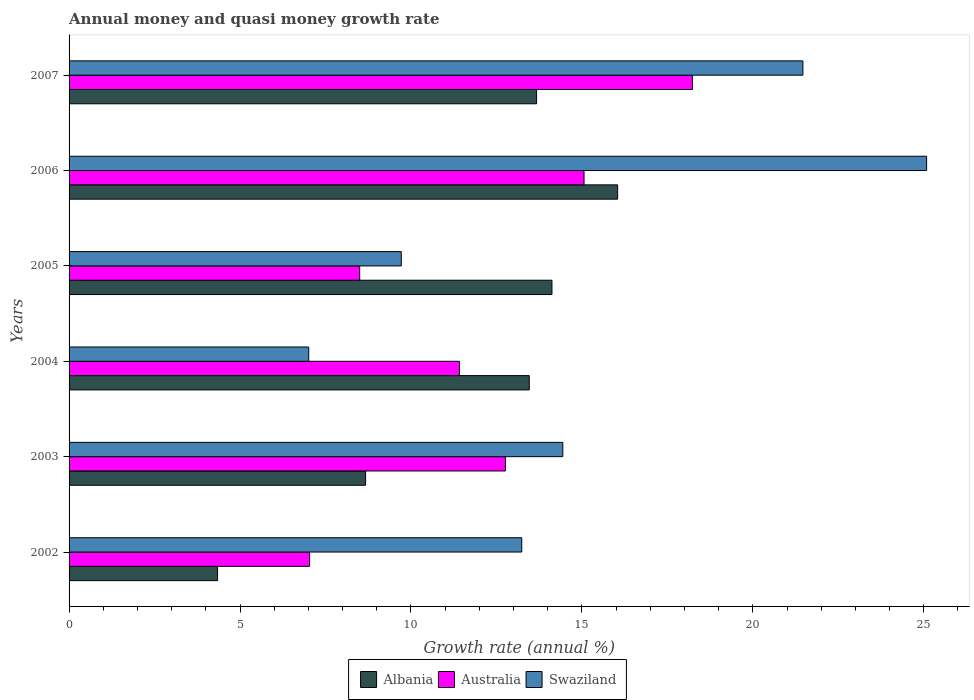Are the number of bars per tick equal to the number of legend labels?
Provide a short and direct response. Yes. How many bars are there on the 5th tick from the bottom?
Your answer should be very brief. 3. In how many cases, is the number of bars for a given year not equal to the number of legend labels?
Your response must be concise. 0. What is the growth rate in Swaziland in 2002?
Provide a succinct answer. 13.24. Across all years, what is the maximum growth rate in Albania?
Give a very brief answer. 16.05. Across all years, what is the minimum growth rate in Australia?
Your answer should be compact. 7.04. In which year was the growth rate in Albania maximum?
Offer a very short reply. 2006. In which year was the growth rate in Australia minimum?
Offer a terse response. 2002. What is the total growth rate in Albania in the graph?
Offer a terse response. 70.32. What is the difference between the growth rate in Australia in 2002 and that in 2005?
Offer a very short reply. -1.46. What is the difference between the growth rate in Albania in 2006 and the growth rate in Swaziland in 2003?
Your response must be concise. 1.6. What is the average growth rate in Albania per year?
Offer a very short reply. 11.72. In the year 2005, what is the difference between the growth rate in Australia and growth rate in Albania?
Offer a very short reply. -5.62. In how many years, is the growth rate in Australia greater than 19 %?
Provide a short and direct response. 0. What is the ratio of the growth rate in Swaziland in 2004 to that in 2006?
Your answer should be compact. 0.28. What is the difference between the highest and the second highest growth rate in Australia?
Give a very brief answer. 3.17. What is the difference between the highest and the lowest growth rate in Australia?
Give a very brief answer. 11.2. What does the 3rd bar from the top in 2003 represents?
Offer a terse response. Albania. What does the 1st bar from the bottom in 2005 represents?
Give a very brief answer. Albania. Is it the case that in every year, the sum of the growth rate in Swaziland and growth rate in Australia is greater than the growth rate in Albania?
Provide a succinct answer. Yes. How many bars are there?
Your answer should be very brief. 18. Are all the bars in the graph horizontal?
Provide a short and direct response. Yes. How many years are there in the graph?
Your answer should be very brief. 6. What is the difference between two consecutive major ticks on the X-axis?
Provide a short and direct response. 5. Does the graph contain grids?
Provide a short and direct response. No. What is the title of the graph?
Provide a succinct answer. Annual money and quasi money growth rate. What is the label or title of the X-axis?
Your response must be concise. Growth rate (annual %). What is the Growth rate (annual %) in Albania in 2002?
Your answer should be compact. 4.34. What is the Growth rate (annual %) in Australia in 2002?
Provide a succinct answer. 7.04. What is the Growth rate (annual %) of Swaziland in 2002?
Keep it short and to the point. 13.24. What is the Growth rate (annual %) in Albania in 2003?
Provide a short and direct response. 8.67. What is the Growth rate (annual %) of Australia in 2003?
Provide a short and direct response. 12.76. What is the Growth rate (annual %) of Swaziland in 2003?
Keep it short and to the point. 14.44. What is the Growth rate (annual %) in Albania in 2004?
Keep it short and to the point. 13.46. What is the Growth rate (annual %) of Australia in 2004?
Keep it short and to the point. 11.42. What is the Growth rate (annual %) in Swaziland in 2004?
Ensure brevity in your answer.  7.01. What is the Growth rate (annual %) of Albania in 2005?
Provide a succinct answer. 14.13. What is the Growth rate (annual %) in Australia in 2005?
Give a very brief answer. 8.5. What is the Growth rate (annual %) in Swaziland in 2005?
Ensure brevity in your answer.  9.72. What is the Growth rate (annual %) in Albania in 2006?
Make the answer very short. 16.05. What is the Growth rate (annual %) in Australia in 2006?
Provide a short and direct response. 15.06. What is the Growth rate (annual %) in Swaziland in 2006?
Keep it short and to the point. 25.08. What is the Growth rate (annual %) of Albania in 2007?
Offer a very short reply. 13.67. What is the Growth rate (annual %) in Australia in 2007?
Offer a terse response. 18.23. What is the Growth rate (annual %) of Swaziland in 2007?
Ensure brevity in your answer.  21.47. Across all years, what is the maximum Growth rate (annual %) of Albania?
Offer a terse response. 16.05. Across all years, what is the maximum Growth rate (annual %) in Australia?
Your response must be concise. 18.23. Across all years, what is the maximum Growth rate (annual %) of Swaziland?
Keep it short and to the point. 25.08. Across all years, what is the minimum Growth rate (annual %) in Albania?
Your answer should be compact. 4.34. Across all years, what is the minimum Growth rate (annual %) of Australia?
Keep it short and to the point. 7.04. Across all years, what is the minimum Growth rate (annual %) in Swaziland?
Your answer should be very brief. 7.01. What is the total Growth rate (annual %) of Albania in the graph?
Give a very brief answer. 70.32. What is the total Growth rate (annual %) in Australia in the graph?
Ensure brevity in your answer.  73.01. What is the total Growth rate (annual %) of Swaziland in the graph?
Give a very brief answer. 90.96. What is the difference between the Growth rate (annual %) of Albania in 2002 and that in 2003?
Your answer should be very brief. -4.33. What is the difference between the Growth rate (annual %) in Australia in 2002 and that in 2003?
Give a very brief answer. -5.73. What is the difference between the Growth rate (annual %) of Swaziland in 2002 and that in 2003?
Provide a short and direct response. -1.2. What is the difference between the Growth rate (annual %) in Albania in 2002 and that in 2004?
Your response must be concise. -9.12. What is the difference between the Growth rate (annual %) of Australia in 2002 and that in 2004?
Ensure brevity in your answer.  -4.38. What is the difference between the Growth rate (annual %) of Swaziland in 2002 and that in 2004?
Your answer should be very brief. 6.23. What is the difference between the Growth rate (annual %) of Albania in 2002 and that in 2005?
Offer a very short reply. -9.78. What is the difference between the Growth rate (annual %) in Australia in 2002 and that in 2005?
Provide a succinct answer. -1.46. What is the difference between the Growth rate (annual %) of Swaziland in 2002 and that in 2005?
Provide a succinct answer. 3.52. What is the difference between the Growth rate (annual %) of Albania in 2002 and that in 2006?
Provide a succinct answer. -11.7. What is the difference between the Growth rate (annual %) in Australia in 2002 and that in 2006?
Provide a short and direct response. -8.03. What is the difference between the Growth rate (annual %) in Swaziland in 2002 and that in 2006?
Your answer should be compact. -11.84. What is the difference between the Growth rate (annual %) of Albania in 2002 and that in 2007?
Ensure brevity in your answer.  -9.33. What is the difference between the Growth rate (annual %) in Australia in 2002 and that in 2007?
Offer a terse response. -11.2. What is the difference between the Growth rate (annual %) in Swaziland in 2002 and that in 2007?
Your response must be concise. -8.22. What is the difference between the Growth rate (annual %) of Albania in 2003 and that in 2004?
Provide a short and direct response. -4.79. What is the difference between the Growth rate (annual %) of Australia in 2003 and that in 2004?
Give a very brief answer. 1.35. What is the difference between the Growth rate (annual %) of Swaziland in 2003 and that in 2004?
Keep it short and to the point. 7.43. What is the difference between the Growth rate (annual %) of Albania in 2003 and that in 2005?
Your response must be concise. -5.45. What is the difference between the Growth rate (annual %) in Australia in 2003 and that in 2005?
Provide a succinct answer. 4.26. What is the difference between the Growth rate (annual %) of Swaziland in 2003 and that in 2005?
Provide a succinct answer. 4.72. What is the difference between the Growth rate (annual %) in Albania in 2003 and that in 2006?
Make the answer very short. -7.37. What is the difference between the Growth rate (annual %) of Australia in 2003 and that in 2006?
Your response must be concise. -2.3. What is the difference between the Growth rate (annual %) of Swaziland in 2003 and that in 2006?
Your answer should be compact. -10.64. What is the difference between the Growth rate (annual %) in Albania in 2003 and that in 2007?
Offer a very short reply. -5. What is the difference between the Growth rate (annual %) in Australia in 2003 and that in 2007?
Make the answer very short. -5.47. What is the difference between the Growth rate (annual %) in Swaziland in 2003 and that in 2007?
Provide a short and direct response. -7.02. What is the difference between the Growth rate (annual %) in Albania in 2004 and that in 2005?
Make the answer very short. -0.66. What is the difference between the Growth rate (annual %) of Australia in 2004 and that in 2005?
Give a very brief answer. 2.92. What is the difference between the Growth rate (annual %) in Swaziland in 2004 and that in 2005?
Offer a very short reply. -2.71. What is the difference between the Growth rate (annual %) in Albania in 2004 and that in 2006?
Ensure brevity in your answer.  -2.58. What is the difference between the Growth rate (annual %) of Australia in 2004 and that in 2006?
Ensure brevity in your answer.  -3.64. What is the difference between the Growth rate (annual %) of Swaziland in 2004 and that in 2006?
Your response must be concise. -18.07. What is the difference between the Growth rate (annual %) in Albania in 2004 and that in 2007?
Provide a succinct answer. -0.21. What is the difference between the Growth rate (annual %) in Australia in 2004 and that in 2007?
Provide a succinct answer. -6.81. What is the difference between the Growth rate (annual %) of Swaziland in 2004 and that in 2007?
Give a very brief answer. -14.46. What is the difference between the Growth rate (annual %) in Albania in 2005 and that in 2006?
Your answer should be compact. -1.92. What is the difference between the Growth rate (annual %) of Australia in 2005 and that in 2006?
Give a very brief answer. -6.56. What is the difference between the Growth rate (annual %) in Swaziland in 2005 and that in 2006?
Your answer should be very brief. -15.37. What is the difference between the Growth rate (annual %) in Albania in 2005 and that in 2007?
Ensure brevity in your answer.  0.45. What is the difference between the Growth rate (annual %) of Australia in 2005 and that in 2007?
Offer a very short reply. -9.73. What is the difference between the Growth rate (annual %) of Swaziland in 2005 and that in 2007?
Provide a succinct answer. -11.75. What is the difference between the Growth rate (annual %) in Albania in 2006 and that in 2007?
Make the answer very short. 2.37. What is the difference between the Growth rate (annual %) of Australia in 2006 and that in 2007?
Your response must be concise. -3.17. What is the difference between the Growth rate (annual %) in Swaziland in 2006 and that in 2007?
Your response must be concise. 3.62. What is the difference between the Growth rate (annual %) of Albania in 2002 and the Growth rate (annual %) of Australia in 2003?
Your answer should be very brief. -8.42. What is the difference between the Growth rate (annual %) in Albania in 2002 and the Growth rate (annual %) in Swaziland in 2003?
Offer a terse response. -10.1. What is the difference between the Growth rate (annual %) of Australia in 2002 and the Growth rate (annual %) of Swaziland in 2003?
Provide a short and direct response. -7.41. What is the difference between the Growth rate (annual %) in Albania in 2002 and the Growth rate (annual %) in Australia in 2004?
Offer a very short reply. -7.07. What is the difference between the Growth rate (annual %) in Albania in 2002 and the Growth rate (annual %) in Swaziland in 2004?
Give a very brief answer. -2.67. What is the difference between the Growth rate (annual %) of Australia in 2002 and the Growth rate (annual %) of Swaziland in 2004?
Ensure brevity in your answer.  0.03. What is the difference between the Growth rate (annual %) of Albania in 2002 and the Growth rate (annual %) of Australia in 2005?
Provide a succinct answer. -4.16. What is the difference between the Growth rate (annual %) in Albania in 2002 and the Growth rate (annual %) in Swaziland in 2005?
Your answer should be very brief. -5.37. What is the difference between the Growth rate (annual %) in Australia in 2002 and the Growth rate (annual %) in Swaziland in 2005?
Provide a succinct answer. -2.68. What is the difference between the Growth rate (annual %) of Albania in 2002 and the Growth rate (annual %) of Australia in 2006?
Ensure brevity in your answer.  -10.72. What is the difference between the Growth rate (annual %) of Albania in 2002 and the Growth rate (annual %) of Swaziland in 2006?
Offer a very short reply. -20.74. What is the difference between the Growth rate (annual %) in Australia in 2002 and the Growth rate (annual %) in Swaziland in 2006?
Ensure brevity in your answer.  -18.05. What is the difference between the Growth rate (annual %) in Albania in 2002 and the Growth rate (annual %) in Australia in 2007?
Offer a very short reply. -13.89. What is the difference between the Growth rate (annual %) in Albania in 2002 and the Growth rate (annual %) in Swaziland in 2007?
Give a very brief answer. -17.12. What is the difference between the Growth rate (annual %) in Australia in 2002 and the Growth rate (annual %) in Swaziland in 2007?
Provide a short and direct response. -14.43. What is the difference between the Growth rate (annual %) in Albania in 2003 and the Growth rate (annual %) in Australia in 2004?
Make the answer very short. -2.75. What is the difference between the Growth rate (annual %) of Albania in 2003 and the Growth rate (annual %) of Swaziland in 2004?
Provide a succinct answer. 1.66. What is the difference between the Growth rate (annual %) of Australia in 2003 and the Growth rate (annual %) of Swaziland in 2004?
Ensure brevity in your answer.  5.75. What is the difference between the Growth rate (annual %) of Albania in 2003 and the Growth rate (annual %) of Australia in 2005?
Your answer should be compact. 0.17. What is the difference between the Growth rate (annual %) of Albania in 2003 and the Growth rate (annual %) of Swaziland in 2005?
Provide a short and direct response. -1.04. What is the difference between the Growth rate (annual %) in Australia in 2003 and the Growth rate (annual %) in Swaziland in 2005?
Ensure brevity in your answer.  3.05. What is the difference between the Growth rate (annual %) in Albania in 2003 and the Growth rate (annual %) in Australia in 2006?
Make the answer very short. -6.39. What is the difference between the Growth rate (annual %) in Albania in 2003 and the Growth rate (annual %) in Swaziland in 2006?
Give a very brief answer. -16.41. What is the difference between the Growth rate (annual %) of Australia in 2003 and the Growth rate (annual %) of Swaziland in 2006?
Your answer should be compact. -12.32. What is the difference between the Growth rate (annual %) of Albania in 2003 and the Growth rate (annual %) of Australia in 2007?
Provide a succinct answer. -9.56. What is the difference between the Growth rate (annual %) in Albania in 2003 and the Growth rate (annual %) in Swaziland in 2007?
Offer a very short reply. -12.79. What is the difference between the Growth rate (annual %) in Australia in 2003 and the Growth rate (annual %) in Swaziland in 2007?
Provide a succinct answer. -8.7. What is the difference between the Growth rate (annual %) of Albania in 2004 and the Growth rate (annual %) of Australia in 2005?
Your response must be concise. 4.96. What is the difference between the Growth rate (annual %) of Albania in 2004 and the Growth rate (annual %) of Swaziland in 2005?
Your answer should be compact. 3.74. What is the difference between the Growth rate (annual %) of Australia in 2004 and the Growth rate (annual %) of Swaziland in 2005?
Provide a short and direct response. 1.7. What is the difference between the Growth rate (annual %) of Albania in 2004 and the Growth rate (annual %) of Australia in 2006?
Ensure brevity in your answer.  -1.6. What is the difference between the Growth rate (annual %) of Albania in 2004 and the Growth rate (annual %) of Swaziland in 2006?
Offer a very short reply. -11.62. What is the difference between the Growth rate (annual %) in Australia in 2004 and the Growth rate (annual %) in Swaziland in 2006?
Offer a terse response. -13.67. What is the difference between the Growth rate (annual %) of Albania in 2004 and the Growth rate (annual %) of Australia in 2007?
Keep it short and to the point. -4.77. What is the difference between the Growth rate (annual %) of Albania in 2004 and the Growth rate (annual %) of Swaziland in 2007?
Keep it short and to the point. -8. What is the difference between the Growth rate (annual %) of Australia in 2004 and the Growth rate (annual %) of Swaziland in 2007?
Keep it short and to the point. -10.05. What is the difference between the Growth rate (annual %) in Albania in 2005 and the Growth rate (annual %) in Australia in 2006?
Provide a succinct answer. -0.94. What is the difference between the Growth rate (annual %) in Albania in 2005 and the Growth rate (annual %) in Swaziland in 2006?
Your answer should be compact. -10.96. What is the difference between the Growth rate (annual %) in Australia in 2005 and the Growth rate (annual %) in Swaziland in 2006?
Your answer should be compact. -16.58. What is the difference between the Growth rate (annual %) in Albania in 2005 and the Growth rate (annual %) in Australia in 2007?
Keep it short and to the point. -4.11. What is the difference between the Growth rate (annual %) in Albania in 2005 and the Growth rate (annual %) in Swaziland in 2007?
Your answer should be very brief. -7.34. What is the difference between the Growth rate (annual %) of Australia in 2005 and the Growth rate (annual %) of Swaziland in 2007?
Your answer should be compact. -12.96. What is the difference between the Growth rate (annual %) of Albania in 2006 and the Growth rate (annual %) of Australia in 2007?
Provide a succinct answer. -2.19. What is the difference between the Growth rate (annual %) of Albania in 2006 and the Growth rate (annual %) of Swaziland in 2007?
Keep it short and to the point. -5.42. What is the difference between the Growth rate (annual %) in Australia in 2006 and the Growth rate (annual %) in Swaziland in 2007?
Provide a short and direct response. -6.4. What is the average Growth rate (annual %) in Albania per year?
Provide a succinct answer. 11.72. What is the average Growth rate (annual %) of Australia per year?
Your response must be concise. 12.17. What is the average Growth rate (annual %) in Swaziland per year?
Your response must be concise. 15.16. In the year 2002, what is the difference between the Growth rate (annual %) in Albania and Growth rate (annual %) in Australia?
Your answer should be very brief. -2.69. In the year 2002, what is the difference between the Growth rate (annual %) of Albania and Growth rate (annual %) of Swaziland?
Keep it short and to the point. -8.9. In the year 2002, what is the difference between the Growth rate (annual %) of Australia and Growth rate (annual %) of Swaziland?
Provide a short and direct response. -6.21. In the year 2003, what is the difference between the Growth rate (annual %) of Albania and Growth rate (annual %) of Australia?
Offer a terse response. -4.09. In the year 2003, what is the difference between the Growth rate (annual %) of Albania and Growth rate (annual %) of Swaziland?
Your answer should be very brief. -5.77. In the year 2003, what is the difference between the Growth rate (annual %) of Australia and Growth rate (annual %) of Swaziland?
Your answer should be compact. -1.68. In the year 2004, what is the difference between the Growth rate (annual %) of Albania and Growth rate (annual %) of Australia?
Ensure brevity in your answer.  2.04. In the year 2004, what is the difference between the Growth rate (annual %) in Albania and Growth rate (annual %) in Swaziland?
Make the answer very short. 6.45. In the year 2004, what is the difference between the Growth rate (annual %) of Australia and Growth rate (annual %) of Swaziland?
Your answer should be compact. 4.41. In the year 2005, what is the difference between the Growth rate (annual %) of Albania and Growth rate (annual %) of Australia?
Your answer should be compact. 5.62. In the year 2005, what is the difference between the Growth rate (annual %) in Albania and Growth rate (annual %) in Swaziland?
Ensure brevity in your answer.  4.41. In the year 2005, what is the difference between the Growth rate (annual %) in Australia and Growth rate (annual %) in Swaziland?
Offer a very short reply. -1.22. In the year 2006, what is the difference between the Growth rate (annual %) of Albania and Growth rate (annual %) of Australia?
Make the answer very short. 0.98. In the year 2006, what is the difference between the Growth rate (annual %) of Albania and Growth rate (annual %) of Swaziland?
Your response must be concise. -9.04. In the year 2006, what is the difference between the Growth rate (annual %) of Australia and Growth rate (annual %) of Swaziland?
Provide a short and direct response. -10.02. In the year 2007, what is the difference between the Growth rate (annual %) in Albania and Growth rate (annual %) in Australia?
Your answer should be very brief. -4.56. In the year 2007, what is the difference between the Growth rate (annual %) of Albania and Growth rate (annual %) of Swaziland?
Your response must be concise. -7.79. In the year 2007, what is the difference between the Growth rate (annual %) of Australia and Growth rate (annual %) of Swaziland?
Provide a succinct answer. -3.23. What is the ratio of the Growth rate (annual %) in Albania in 2002 to that in 2003?
Your answer should be compact. 0.5. What is the ratio of the Growth rate (annual %) in Australia in 2002 to that in 2003?
Your response must be concise. 0.55. What is the ratio of the Growth rate (annual %) in Swaziland in 2002 to that in 2003?
Your answer should be compact. 0.92. What is the ratio of the Growth rate (annual %) of Albania in 2002 to that in 2004?
Provide a short and direct response. 0.32. What is the ratio of the Growth rate (annual %) in Australia in 2002 to that in 2004?
Give a very brief answer. 0.62. What is the ratio of the Growth rate (annual %) of Swaziland in 2002 to that in 2004?
Provide a succinct answer. 1.89. What is the ratio of the Growth rate (annual %) in Albania in 2002 to that in 2005?
Provide a short and direct response. 0.31. What is the ratio of the Growth rate (annual %) in Australia in 2002 to that in 2005?
Provide a succinct answer. 0.83. What is the ratio of the Growth rate (annual %) of Swaziland in 2002 to that in 2005?
Provide a short and direct response. 1.36. What is the ratio of the Growth rate (annual %) in Albania in 2002 to that in 2006?
Offer a terse response. 0.27. What is the ratio of the Growth rate (annual %) of Australia in 2002 to that in 2006?
Provide a succinct answer. 0.47. What is the ratio of the Growth rate (annual %) in Swaziland in 2002 to that in 2006?
Provide a short and direct response. 0.53. What is the ratio of the Growth rate (annual %) in Albania in 2002 to that in 2007?
Offer a terse response. 0.32. What is the ratio of the Growth rate (annual %) in Australia in 2002 to that in 2007?
Provide a succinct answer. 0.39. What is the ratio of the Growth rate (annual %) of Swaziland in 2002 to that in 2007?
Your response must be concise. 0.62. What is the ratio of the Growth rate (annual %) of Albania in 2003 to that in 2004?
Your answer should be very brief. 0.64. What is the ratio of the Growth rate (annual %) in Australia in 2003 to that in 2004?
Your answer should be compact. 1.12. What is the ratio of the Growth rate (annual %) of Swaziland in 2003 to that in 2004?
Provide a short and direct response. 2.06. What is the ratio of the Growth rate (annual %) in Albania in 2003 to that in 2005?
Ensure brevity in your answer.  0.61. What is the ratio of the Growth rate (annual %) in Australia in 2003 to that in 2005?
Keep it short and to the point. 1.5. What is the ratio of the Growth rate (annual %) of Swaziland in 2003 to that in 2005?
Your response must be concise. 1.49. What is the ratio of the Growth rate (annual %) in Albania in 2003 to that in 2006?
Ensure brevity in your answer.  0.54. What is the ratio of the Growth rate (annual %) of Australia in 2003 to that in 2006?
Make the answer very short. 0.85. What is the ratio of the Growth rate (annual %) in Swaziland in 2003 to that in 2006?
Keep it short and to the point. 0.58. What is the ratio of the Growth rate (annual %) in Albania in 2003 to that in 2007?
Offer a very short reply. 0.63. What is the ratio of the Growth rate (annual %) of Swaziland in 2003 to that in 2007?
Ensure brevity in your answer.  0.67. What is the ratio of the Growth rate (annual %) in Albania in 2004 to that in 2005?
Provide a short and direct response. 0.95. What is the ratio of the Growth rate (annual %) in Australia in 2004 to that in 2005?
Your response must be concise. 1.34. What is the ratio of the Growth rate (annual %) in Swaziland in 2004 to that in 2005?
Your answer should be very brief. 0.72. What is the ratio of the Growth rate (annual %) of Albania in 2004 to that in 2006?
Offer a terse response. 0.84. What is the ratio of the Growth rate (annual %) in Australia in 2004 to that in 2006?
Provide a succinct answer. 0.76. What is the ratio of the Growth rate (annual %) of Swaziland in 2004 to that in 2006?
Make the answer very short. 0.28. What is the ratio of the Growth rate (annual %) of Albania in 2004 to that in 2007?
Ensure brevity in your answer.  0.98. What is the ratio of the Growth rate (annual %) in Australia in 2004 to that in 2007?
Provide a succinct answer. 0.63. What is the ratio of the Growth rate (annual %) in Swaziland in 2004 to that in 2007?
Provide a succinct answer. 0.33. What is the ratio of the Growth rate (annual %) of Albania in 2005 to that in 2006?
Your response must be concise. 0.88. What is the ratio of the Growth rate (annual %) of Australia in 2005 to that in 2006?
Ensure brevity in your answer.  0.56. What is the ratio of the Growth rate (annual %) in Swaziland in 2005 to that in 2006?
Make the answer very short. 0.39. What is the ratio of the Growth rate (annual %) in Albania in 2005 to that in 2007?
Make the answer very short. 1.03. What is the ratio of the Growth rate (annual %) of Australia in 2005 to that in 2007?
Offer a terse response. 0.47. What is the ratio of the Growth rate (annual %) in Swaziland in 2005 to that in 2007?
Keep it short and to the point. 0.45. What is the ratio of the Growth rate (annual %) of Albania in 2006 to that in 2007?
Provide a short and direct response. 1.17. What is the ratio of the Growth rate (annual %) in Australia in 2006 to that in 2007?
Keep it short and to the point. 0.83. What is the ratio of the Growth rate (annual %) of Swaziland in 2006 to that in 2007?
Offer a very short reply. 1.17. What is the difference between the highest and the second highest Growth rate (annual %) of Albania?
Your answer should be very brief. 1.92. What is the difference between the highest and the second highest Growth rate (annual %) of Australia?
Offer a terse response. 3.17. What is the difference between the highest and the second highest Growth rate (annual %) in Swaziland?
Offer a terse response. 3.62. What is the difference between the highest and the lowest Growth rate (annual %) of Albania?
Offer a terse response. 11.7. What is the difference between the highest and the lowest Growth rate (annual %) of Australia?
Keep it short and to the point. 11.2. What is the difference between the highest and the lowest Growth rate (annual %) of Swaziland?
Your answer should be very brief. 18.07. 